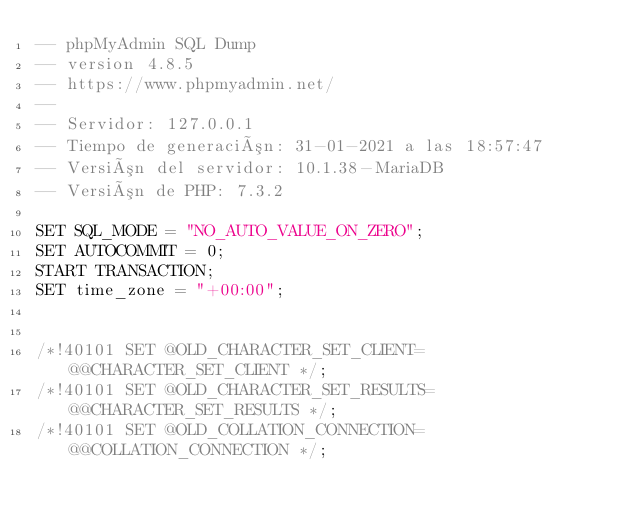Convert code to text. <code><loc_0><loc_0><loc_500><loc_500><_SQL_>-- phpMyAdmin SQL Dump
-- version 4.8.5
-- https://www.phpmyadmin.net/
--
-- Servidor: 127.0.0.1
-- Tiempo de generación: 31-01-2021 a las 18:57:47
-- Versión del servidor: 10.1.38-MariaDB
-- Versión de PHP: 7.3.2

SET SQL_MODE = "NO_AUTO_VALUE_ON_ZERO";
SET AUTOCOMMIT = 0;
START TRANSACTION;
SET time_zone = "+00:00";


/*!40101 SET @OLD_CHARACTER_SET_CLIENT=@@CHARACTER_SET_CLIENT */;
/*!40101 SET @OLD_CHARACTER_SET_RESULTS=@@CHARACTER_SET_RESULTS */;
/*!40101 SET @OLD_COLLATION_CONNECTION=@@COLLATION_CONNECTION */;</code> 